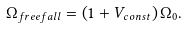Convert formula to latex. <formula><loc_0><loc_0><loc_500><loc_500>\Omega _ { f r e e f a l l } = \left ( 1 + { V _ { c o n s t } } \right ) \Omega _ { 0 } .</formula> 